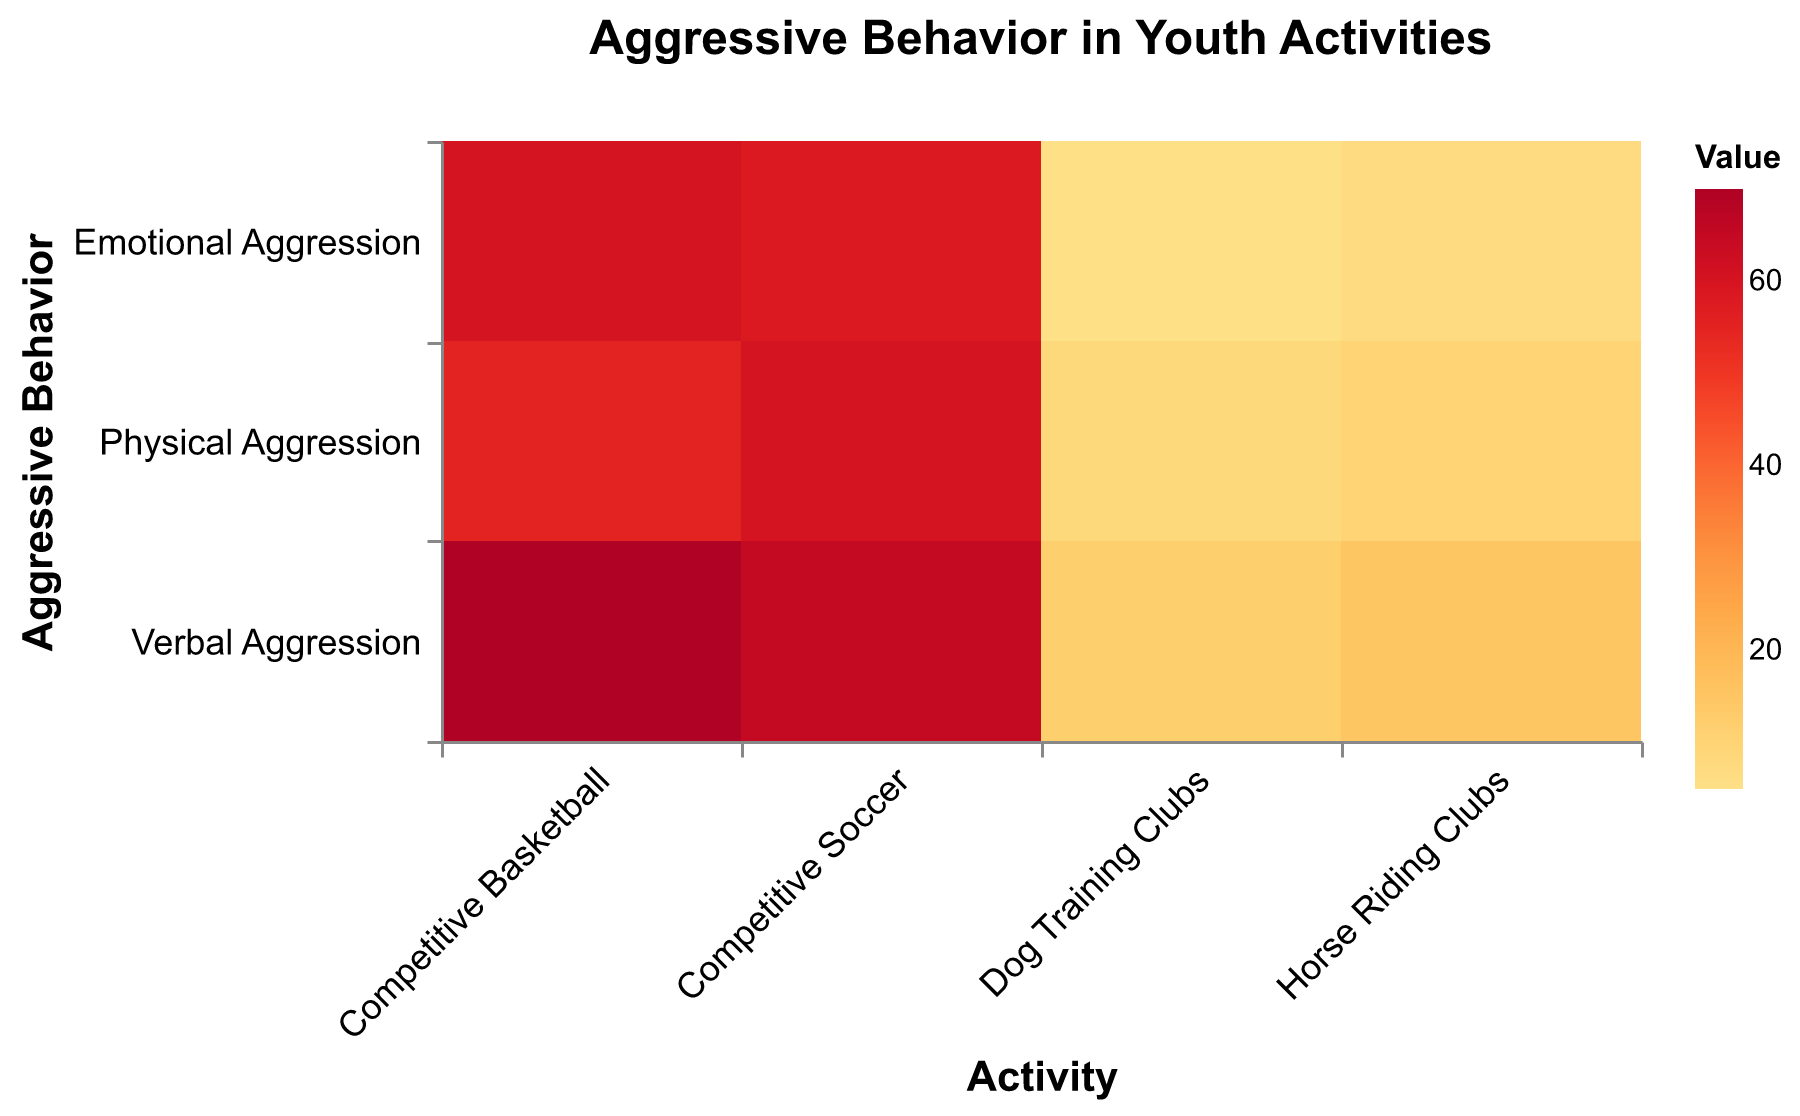What's the title of the figure? The title of the figure is usually positioned at the top in larger or bold text for easy visibility. It helps users understand the overall topic or main idea represented by the data in the plot.
Answer: Aggressive Behavior in Youth Activities Which activity shows the highest level of physical aggression? To identify the highest level of physical aggression, look at the cells corresponding to "Physical Aggression" and compare their color intensity. The darkest color indicates the highest value.
Answer: Competitive Soccer What's the value of verbal aggression in dog training clubs? By examining the cell at the intersection of "Verbal Aggression" and "Dog Training Clubs," we can read the value indicated.
Answer: 12 Which type of aggression has the lowest value in horse riding clubs? To find the lowest value, scan the cells under "Horse Riding Clubs" and compare the values of verbal, physical, and emotional aggression. The lowest value among these is the answer.
Answer: Emotional Aggression Compare verbal aggression levels between competitive sports and animal-related activities. Which category has higher values overall? Summing up the values of verbal aggression for the sports (basketball and soccer) and separately for the animal-related activities (dog training and horse riding) will reveal which group has higher values. For sports: 70 + 65 = 135, for animal-related: 12 + 15 = 27.
Answer: Competitive Sports Which activity has the lowest overall level of aggression? Sum all types of aggression for each activity and identify which has the lowest total. For dog training: 12+8+5=25, horse riding: 15+10+7=32, basketball: 70+55+60=185, soccer: 65+60+58=183.
Answer: Dog Training Clubs Is emotional aggression higher in competitive basketball or horse riding clubs? Compare the color intensity or numeric values of emotional aggression between competitive basketball and horse riding clubs.
Answer: Competitive Basketball How many cases of physical aggression are recorded in competitive basketball versus horse riding clubs? Directly compare the values for physical aggression in both activities.
Answer: Basketball: 55, Horse Riding: 10 What is the average value of aggressive behaviors in competitive soccer? Calculate the mean of verbal, physical, and emotional aggression values in soccer: (65 + 60 + 58) / 3 = 61.
Answer: 61 Which aggressive behavior type is most prevalent in dog training clubs? Compare the values of verbal, physical, and emotional aggression within dog training clubs, and the highest value represents the most prevalent aggressive behavior type.
Answer: Verbal Aggression 